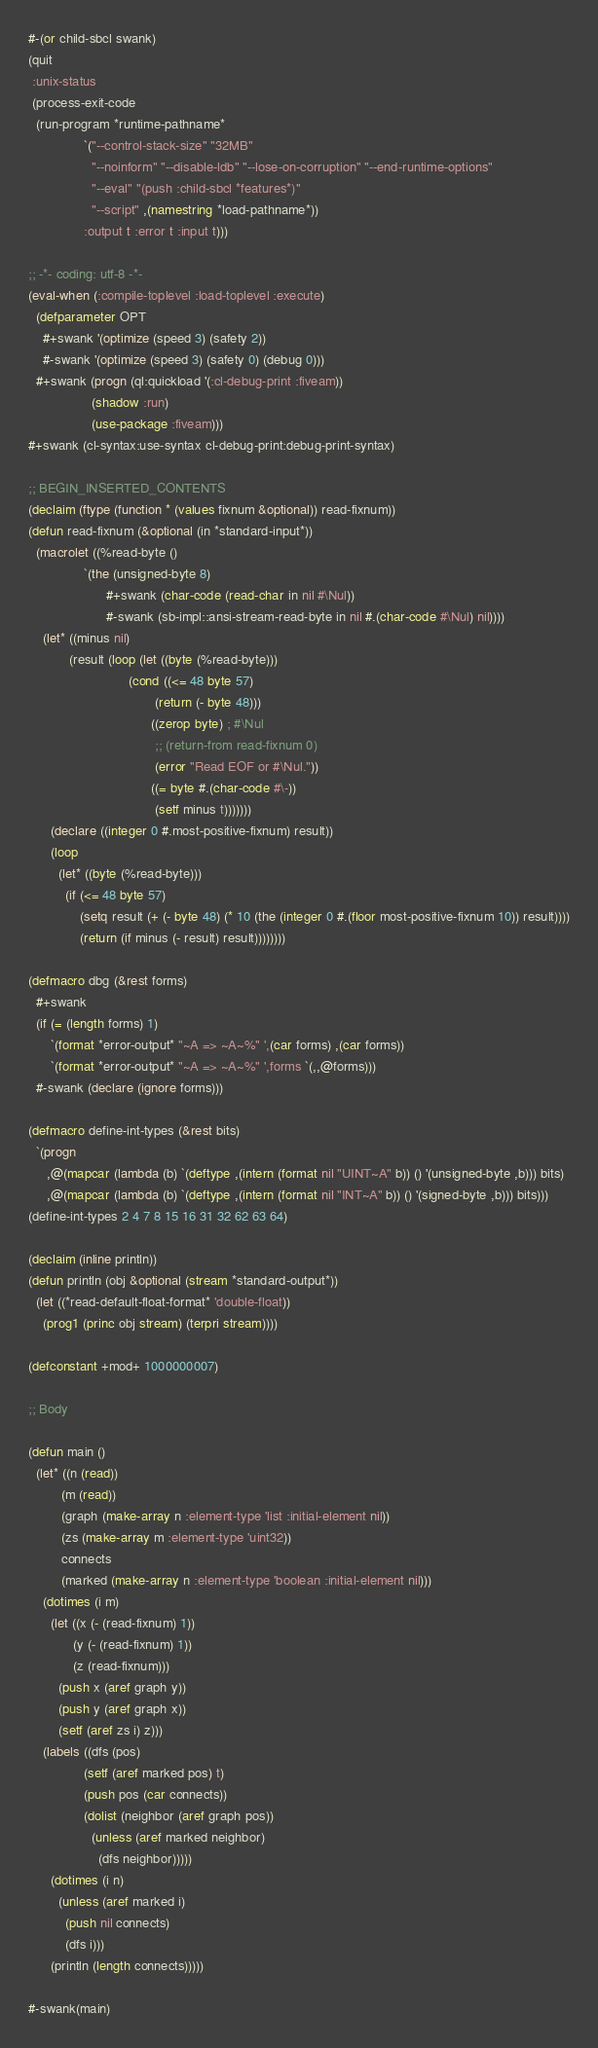<code> <loc_0><loc_0><loc_500><loc_500><_Lisp_>#-(or child-sbcl swank)
(quit
 :unix-status
 (process-exit-code
  (run-program *runtime-pathname*
               `("--control-stack-size" "32MB"
                 "--noinform" "--disable-ldb" "--lose-on-corruption" "--end-runtime-options"
                 "--eval" "(push :child-sbcl *features*)"
                 "--script" ,(namestring *load-pathname*))
               :output t :error t :input t)))

;; -*- coding: utf-8 -*-
(eval-when (:compile-toplevel :load-toplevel :execute)
  (defparameter OPT
    #+swank '(optimize (speed 3) (safety 2))
    #-swank '(optimize (speed 3) (safety 0) (debug 0)))
  #+swank (progn (ql:quickload '(:cl-debug-print :fiveam))
                 (shadow :run)
                 (use-package :fiveam)))
#+swank (cl-syntax:use-syntax cl-debug-print:debug-print-syntax)

;; BEGIN_INSERTED_CONTENTS
(declaim (ftype (function * (values fixnum &optional)) read-fixnum))
(defun read-fixnum (&optional (in *standard-input*))
  (macrolet ((%read-byte ()
               `(the (unsigned-byte 8)
                     #+swank (char-code (read-char in nil #\Nul))
                     #-swank (sb-impl::ansi-stream-read-byte in nil #.(char-code #\Nul) nil))))
    (let* ((minus nil)
           (result (loop (let ((byte (%read-byte)))
                           (cond ((<= 48 byte 57)
                                  (return (- byte 48)))
                                 ((zerop byte) ; #\Nul
                                  ;; (return-from read-fixnum 0)
                                  (error "Read EOF or #\Nul."))
                                 ((= byte #.(char-code #\-))
                                  (setf minus t)))))))
      (declare ((integer 0 #.most-positive-fixnum) result))
      (loop
        (let* ((byte (%read-byte)))
          (if (<= 48 byte 57)
              (setq result (+ (- byte 48) (* 10 (the (integer 0 #.(floor most-positive-fixnum 10)) result))))
              (return (if minus (- result) result))))))))

(defmacro dbg (&rest forms)
  #+swank
  (if (= (length forms) 1)
      `(format *error-output* "~A => ~A~%" ',(car forms) ,(car forms))
      `(format *error-output* "~A => ~A~%" ',forms `(,,@forms)))
  #-swank (declare (ignore forms)))

(defmacro define-int-types (&rest bits)
  `(progn
     ,@(mapcar (lambda (b) `(deftype ,(intern (format nil "UINT~A" b)) () '(unsigned-byte ,b))) bits)
     ,@(mapcar (lambda (b) `(deftype ,(intern (format nil "INT~A" b)) () '(signed-byte ,b))) bits)))
(define-int-types 2 4 7 8 15 16 31 32 62 63 64)

(declaim (inline println))
(defun println (obj &optional (stream *standard-output*))
  (let ((*read-default-float-format* 'double-float))
    (prog1 (princ obj stream) (terpri stream))))

(defconstant +mod+ 1000000007)

;; Body

(defun main ()
  (let* ((n (read))
         (m (read))
         (graph (make-array n :element-type 'list :initial-element nil))
         (zs (make-array m :element-type 'uint32))
         connects
         (marked (make-array n :element-type 'boolean :initial-element nil)))
    (dotimes (i m)
      (let ((x (- (read-fixnum) 1))
            (y (- (read-fixnum) 1))
            (z (read-fixnum)))
        (push x (aref graph y))
        (push y (aref graph x))
        (setf (aref zs i) z)))
    (labels ((dfs (pos)
               (setf (aref marked pos) t)
               (push pos (car connects))
               (dolist (neighbor (aref graph pos))
                 (unless (aref marked neighbor)
                   (dfs neighbor)))))
      (dotimes (i n)
        (unless (aref marked i)
          (push nil connects)
          (dfs i)))
      (println (length connects)))))

#-swank(main)

</code> 